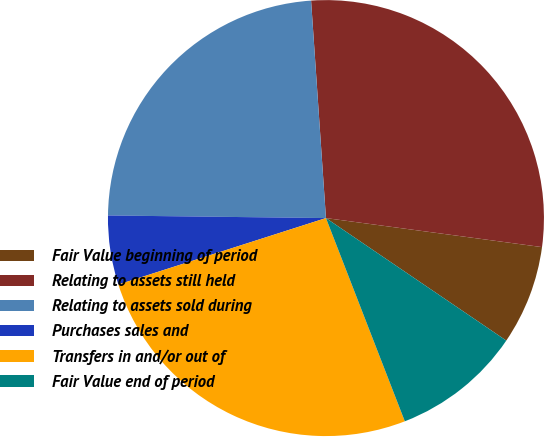Convert chart. <chart><loc_0><loc_0><loc_500><loc_500><pie_chart><fcel>Fair Value beginning of period<fcel>Relating to assets still held<fcel>Relating to assets sold during<fcel>Purchases sales and<fcel>Transfers in and/or out of<fcel>Fair Value end of period<nl><fcel>7.37%<fcel>28.21%<fcel>23.72%<fcel>5.12%<fcel>25.96%<fcel>9.61%<nl></chart> 